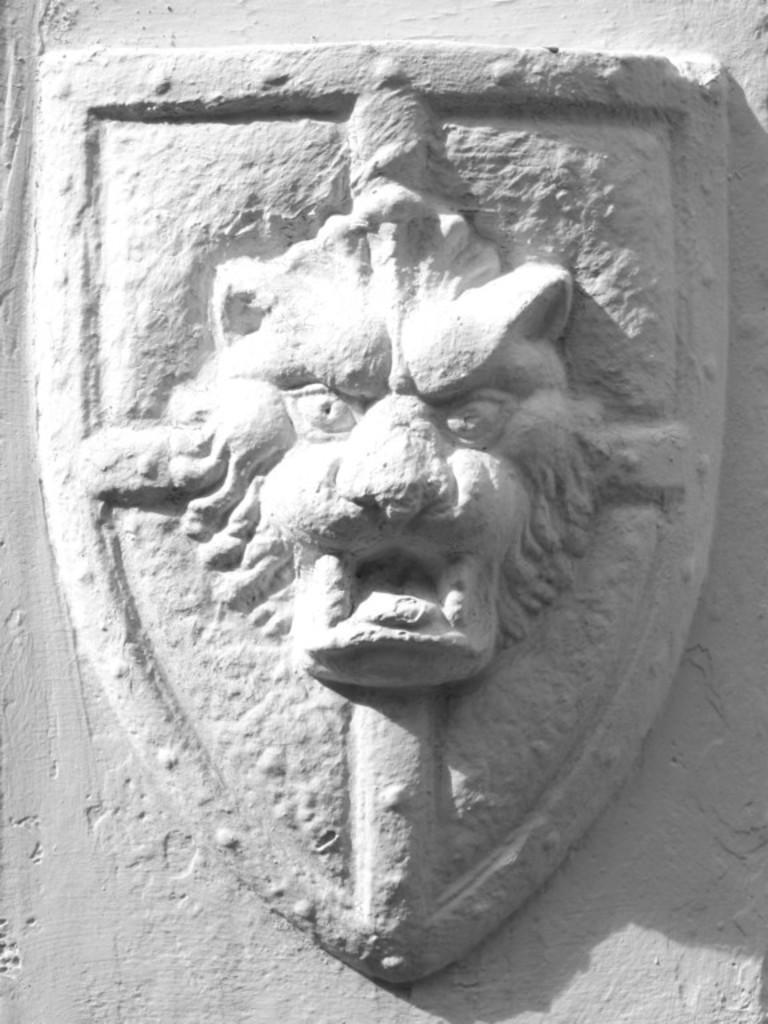What can be seen on the wall in the image? There is a stone carving on the wall in the image. Can you describe the stone carving in more detail? Unfortunately, the image does not provide enough detail to describe the stone carving further. What type of material is the wall made of? The material of the wall is not specified in the image. How many dolls are balanced on the stone carving in the image? There are no dolls present in the image, and the stone carving is not depicted as a surface for balancing objects. 